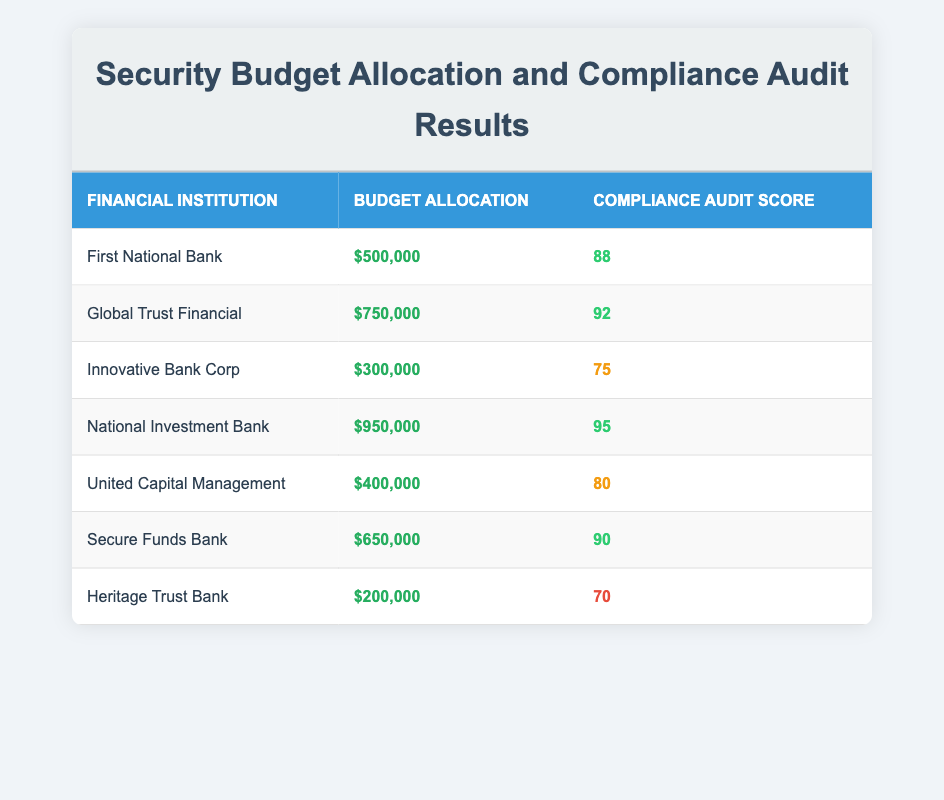What is the highest compliance audit score? To find the highest compliance audit score, look through the "Compliance Audit Score" column and identify the maximum value, which is 95 for the National Investment Bank.
Answer: 95 Which financial institution has a budget allocation of 400,000? By examining the "Budget Allocation" column, we can see that United Capital Management has a budget allocation of 400,000.
Answer: United Capital Management What is the average budget allocation for all institutions? To calculate the average budget allocation, first sum all budget allocations: 500,000 + 750,000 + 300,000 + 950,000 + 400,000 + 650,000 + 200,000 = 2,750,000. Then divide by the number of institutions (7): 2,750,000 / 7 ≈ 392,857.14.
Answer: 392,857.14 Is there any institution that has a score below 75? Looking at the "Compliance Audit Score" column, the lowest score is 70 for Heritage Trust Bank, which confirms that there is indeed an institution with a score below 75.
Answer: Yes What is the total budget allocation for institutions with a compliance audit score of 90 or higher? First, identify institutions with scores of 90 or higher: Global Trust Financial (750,000), National Investment Bank (950,000), and Secure Funds Bank (650,000). Next, sum their budget allocations: 750,000 + 950,000 + 650,000 = 2,350,000.
Answer: 2,350,000 